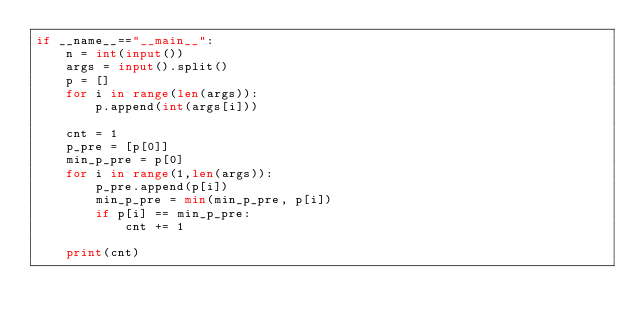<code> <loc_0><loc_0><loc_500><loc_500><_Python_>if __name__=="__main__":
    n = int(input())
    args = input().split()
    p = []
    for i in range(len(args)):
        p.append(int(args[i]))

    cnt = 1
    p_pre = [p[0]]
    min_p_pre = p[0]
    for i in range(1,len(args)):
        p_pre.append(p[i])
        min_p_pre = min(min_p_pre, p[i])
        if p[i] == min_p_pre:
            cnt += 1

    print(cnt)</code> 